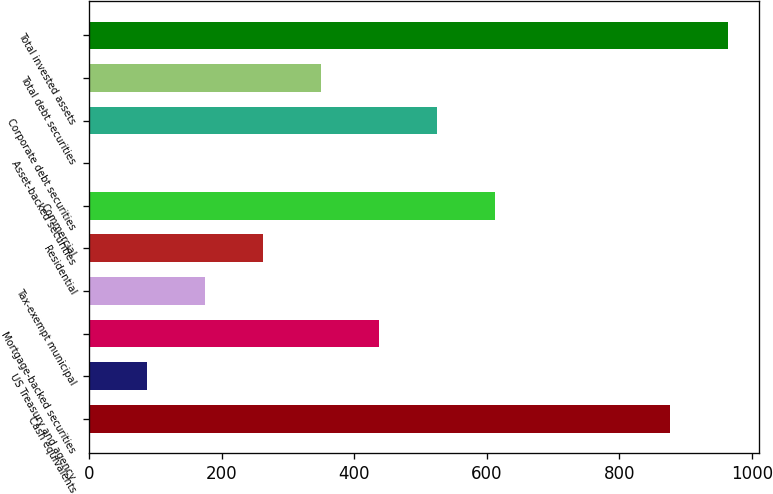Convert chart to OTSL. <chart><loc_0><loc_0><loc_500><loc_500><bar_chart><fcel>Cash equivalents<fcel>US Treasury and agency<fcel>Mortgage-backed securities<fcel>Tax-exempt municipal<fcel>Residential<fcel>Commercial<fcel>Asset-backed securities<fcel>Corporate debt securities<fcel>Total debt securities<fcel>Total invested assets<nl><fcel>876<fcel>88.11<fcel>438.27<fcel>175.65<fcel>263.19<fcel>613.35<fcel>0.57<fcel>525.81<fcel>350.73<fcel>963.54<nl></chart> 